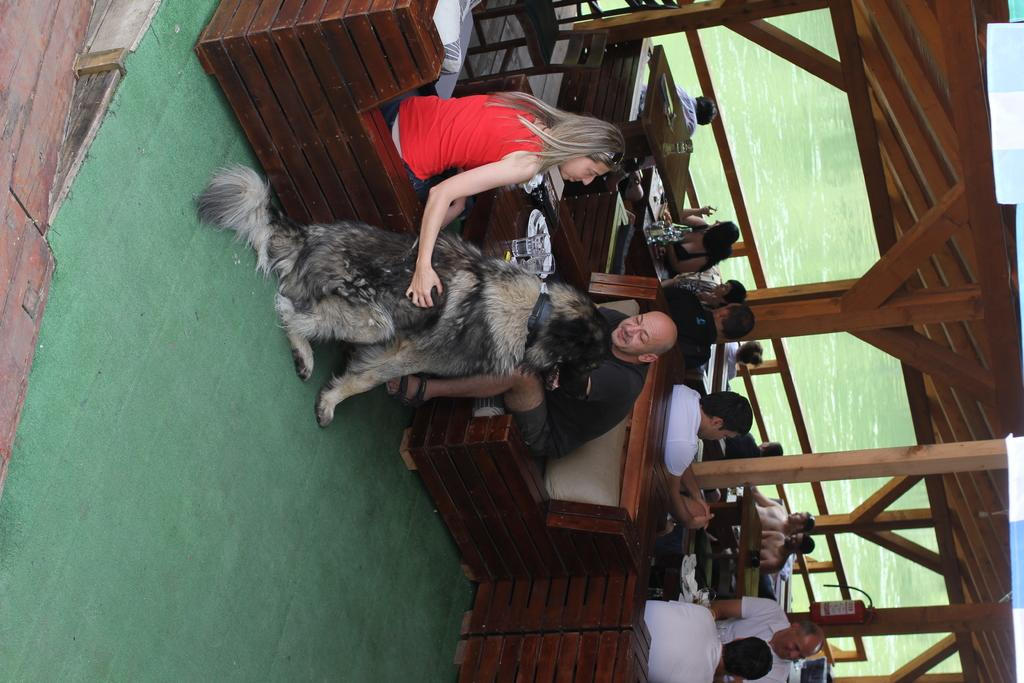What are the people in the image doing? The people in the image are sitting. What can be seen beneath the people in the image? The ground is visible in the image. What type of animal is in the image? There is a dog in the image. What type of furniture is in the image? There are tables in the image. What is covering the area above the people in the image? There is a roof in the image. What is the liquid substance present in the image? Water is present in the image. How many girls are standing on their toes in the image? There are no girls or toes mentioned in the image; it features people sitting, a dog, tables, a roof, and water. 